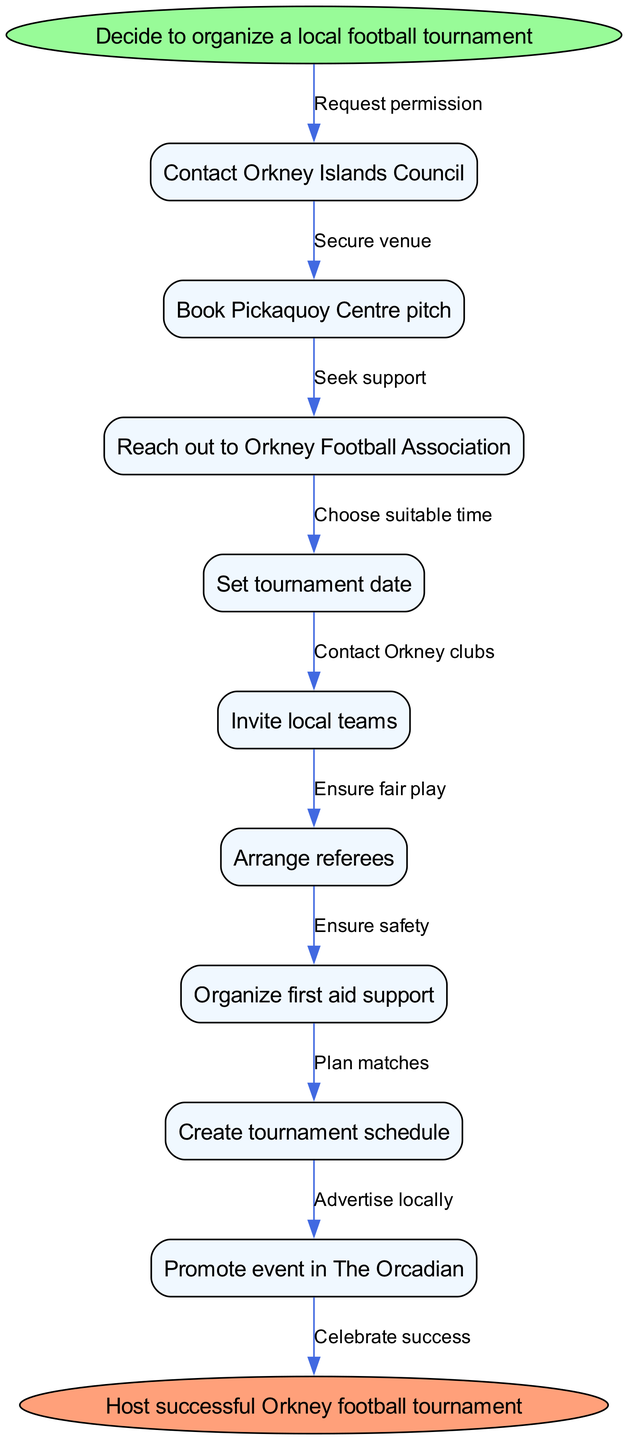What is the first step in organizing the tournament? The first step is to "Decide to organize a local football tournament", which serves as the starting point of the process in the diagram. This is indicated at the top and flows into the next action.
Answer: Decide to organize a local football tournament How many steps are there in total? The diagram outlines 9 specific steps, moving from contacting the Orkney Islands Council to promoting the event in The Orcadian, before concluding with hosting the tournament. Counting all listed actions gives a total of 9 steps.
Answer: 9 Which node follows "Reach out to Orkney Football Association"? The node that follows "Reach out to Orkney Football Association" is "Set tournament date". This relationship is shown through a direct edge connecting these two nodes in the order of operations.
Answer: Set tournament date What is the last action of the flowchart? The final action of the flowchart is "Host successful Orkney football tournament". It is connected from the last step of organizing the tournament, highlighting the flow towards successful execution.
Answer: Host successful Orkney football tournament Which action is intended to ensure fair play? The action aimed at ensuring fair play is "Arrange referees". This step is explicitly included to highlight the importance of fair officiating during the matches in the tournament.
Answer: Arrange referees What is the edge connecting "Book Pickaquoy Centre pitch" and "Reach out to Orkney Football Association"? The edge connecting "Book Pickaquoy Centre pitch" and "Reach out to Orkney Football Association" is "Secure venue". This signifies that after booking the pitch, the next action is to seek support from the football association, thereby ensuring infrastructure support.
Answer: Secure venue What prerequisite is necessary before inviting local teams? It is necessary to "Set tournament date" before inviting local teams. This step establishes a timeline, which is crucial for communicating the invitation properly.
Answer: Set tournament date Which step involves advertising the tournament locally? The step that involves advertising the tournament locally is "Promote event in The Orcadian". This indicates the strategy to reach out to the local community to attract participants and spectators.
Answer: Promote event in The Orcadian What do you need to ensure before organizing the matches? You need to "Organize first aid support" to ensure safety before organizing the matches. This is crucial for the welfare of all participants during the tournament.
Answer: Organize first aid support 